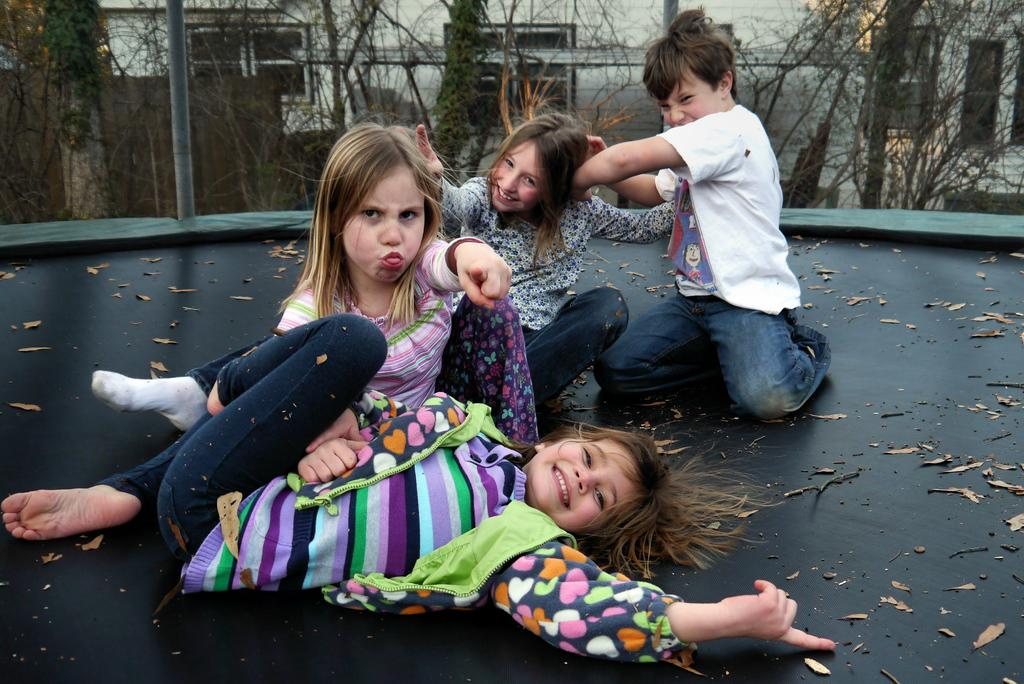What type of vegetation is visible at the top of the image? There are trees at the top of the image. How many people are present in the image? There are four people in the image. What is the gender distribution of the people in the image? Three of the people are girls, and one is a boy. What are the people in the image doing? The people are playing. What scientific experiment is being conducted by the people in the image? There is no indication of a scientific experiment in the image; the people are playing. Is there a jail visible in the image? No, there is no jail present in the image. 